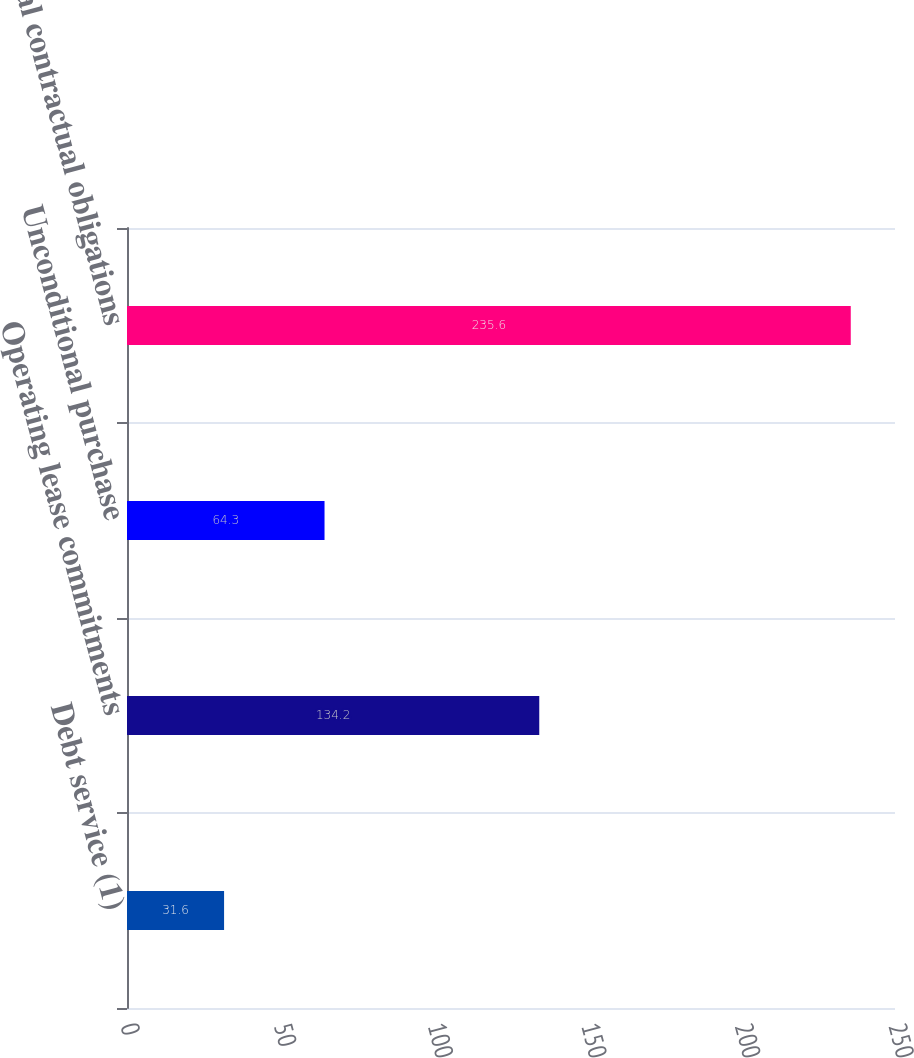<chart> <loc_0><loc_0><loc_500><loc_500><bar_chart><fcel>Debt service (1)<fcel>Operating lease commitments<fcel>Unconditional purchase<fcel>Total contractual obligations<nl><fcel>31.6<fcel>134.2<fcel>64.3<fcel>235.6<nl></chart> 